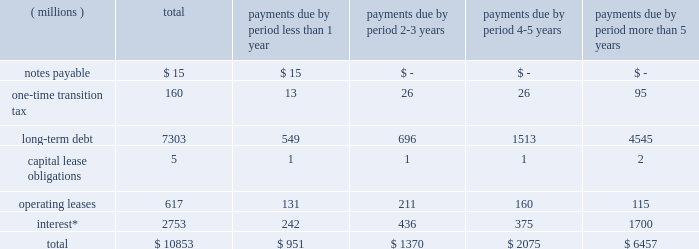Liquidity and capital resources we currently expect to fund all of our cash requirements which are reasonably foreseeable for 2018 , including scheduled debt repayments , new investments in the business , share repurchases , dividend payments , possible business acquisitions and pension contributions , with cash from operating activities , and as needed , additional short-term and/or long-term borrowings .
We continue to expect our operating cash flow to remain strong .
As of december 31 , 2017 , we had $ 211 million of cash and cash equivalents on hand , of which $ 151 million was held outside of the as of december 31 , 2016 , we had $ 327 million of cash and cash equivalents on hand , of which $ 184 million was held outside of the u.s .
As of december 31 , 2015 , we had $ 26 million of deferred tax liabilities for pre-acquisition foreign earnings associated with the legacy nalco entities and legacy champion entities that we intended to repatriate .
These liabilities were recorded as part of the respective purchase price accounting of each transaction .
The remaining foreign earnings were repatriated in 2016 , reducing the deferred tax liabilities to zero at december 31 , 2016 .
As of december 31 , 2017 we had a $ 2.0 billion multi-year credit facility , which expires in november 2022 .
The credit facility has been established with a diverse syndicate of banks .
There were no borrowings under our credit facility as of december 31 , 2017 or 2016 .
The credit facility supports our $ 2.0 billion u.s .
Commercial paper program and $ 2.0 billion european commercial paper program .
Combined borrowing under these two commercial paper programs may not exceed $ 2.0 billion .
At year-end , we had no amount outstanding under the european commercial paper program and no amount outstanding under the u.s .
Commercial paper program .
Additionally , we have uncommitted credit lines of $ 660 million with major international banks and financial institutions to support our general global funding needs .
Most of these lines are used to support global cash pooling structures .
Approximately $ 643 million of these credit lines were available for use as of year-end 2017 .
Bank supported letters of credit , surety bonds and guarantees total $ 198 million and represent commercial business transactions .
We do not have any other significant unconditional purchase obligations or commercial commitments .
As of december 31 , 2017 , our short-term borrowing program was rated a-2 by standard & poor 2019s and p-2 by moody 2019s .
As of december 31 , 2017 , standard & poor 2019s and moody 2019s rated our long-term credit at a- ( stable outlook ) and baa1 ( stable outlook ) , respectively .
A reduction in our credit ratings could limit or preclude our ability to issue commercial paper under our current programs , or could also adversely affect our ability to renew existing , or negotiate new , credit facilities in the future and could increase the cost of these facilities .
Should this occur , we could seek additional sources of funding , including issuing additional term notes or bonds .
In addition , we have the ability , at our option , to draw upon our $ 2.0 billion of committed credit facility .
We are in compliance with our debt covenants and other requirements of our credit agreements and indentures .
A schedule of our various obligations as of december 31 , 2017 are summarized in the table: .
* interest on variable rate debt was calculated using the interest rate at year-end 2017 .
During the fourth quarter of 2017 , we recorded a one-time transition tax related to enactment of the tax act .
The expense is primarily related to the one-time transition tax , which is payable over eight years .
As discussed further in note 12 , this balance is a provisional amount and is subject to adjustment during the measurement period of up to one year following the enactment of the tax act , as provided by recent sec guidance .
As of december 31 , 2017 , our gross liability for uncertain tax positions was $ 68 million .
We are not able to reasonably estimate the amount by which the liability will increase or decrease over an extended period of time or whether a cash settlement of the liability will be required .
Therefore , these amounts have been excluded from the schedule of contractual obligations. .
What percent of operating lease payments are due in less than one year? 
Computations: (131 / 617)
Answer: 0.21232. Liquidity and capital resources we currently expect to fund all of our cash requirements which are reasonably foreseeable for 2018 , including scheduled debt repayments , new investments in the business , share repurchases , dividend payments , possible business acquisitions and pension contributions , with cash from operating activities , and as needed , additional short-term and/or long-term borrowings .
We continue to expect our operating cash flow to remain strong .
As of december 31 , 2017 , we had $ 211 million of cash and cash equivalents on hand , of which $ 151 million was held outside of the as of december 31 , 2016 , we had $ 327 million of cash and cash equivalents on hand , of which $ 184 million was held outside of the u.s .
As of december 31 , 2015 , we had $ 26 million of deferred tax liabilities for pre-acquisition foreign earnings associated with the legacy nalco entities and legacy champion entities that we intended to repatriate .
These liabilities were recorded as part of the respective purchase price accounting of each transaction .
The remaining foreign earnings were repatriated in 2016 , reducing the deferred tax liabilities to zero at december 31 , 2016 .
As of december 31 , 2017 we had a $ 2.0 billion multi-year credit facility , which expires in november 2022 .
The credit facility has been established with a diverse syndicate of banks .
There were no borrowings under our credit facility as of december 31 , 2017 or 2016 .
The credit facility supports our $ 2.0 billion u.s .
Commercial paper program and $ 2.0 billion european commercial paper program .
Combined borrowing under these two commercial paper programs may not exceed $ 2.0 billion .
At year-end , we had no amount outstanding under the european commercial paper program and no amount outstanding under the u.s .
Commercial paper program .
Additionally , we have uncommitted credit lines of $ 660 million with major international banks and financial institutions to support our general global funding needs .
Most of these lines are used to support global cash pooling structures .
Approximately $ 643 million of these credit lines were available for use as of year-end 2017 .
Bank supported letters of credit , surety bonds and guarantees total $ 198 million and represent commercial business transactions .
We do not have any other significant unconditional purchase obligations or commercial commitments .
As of december 31 , 2017 , our short-term borrowing program was rated a-2 by standard & poor 2019s and p-2 by moody 2019s .
As of december 31 , 2017 , standard & poor 2019s and moody 2019s rated our long-term credit at a- ( stable outlook ) and baa1 ( stable outlook ) , respectively .
A reduction in our credit ratings could limit or preclude our ability to issue commercial paper under our current programs , or could also adversely affect our ability to renew existing , or negotiate new , credit facilities in the future and could increase the cost of these facilities .
Should this occur , we could seek additional sources of funding , including issuing additional term notes or bonds .
In addition , we have the ability , at our option , to draw upon our $ 2.0 billion of committed credit facility .
We are in compliance with our debt covenants and other requirements of our credit agreements and indentures .
A schedule of our various obligations as of december 31 , 2017 are summarized in the table: .
* interest on variable rate debt was calculated using the interest rate at year-end 2017 .
During the fourth quarter of 2017 , we recorded a one-time transition tax related to enactment of the tax act .
The expense is primarily related to the one-time transition tax , which is payable over eight years .
As discussed further in note 12 , this balance is a provisional amount and is subject to adjustment during the measurement period of up to one year following the enactment of the tax act , as provided by recent sec guidance .
As of december 31 , 2017 , our gross liability for uncertain tax positions was $ 68 million .
We are not able to reasonably estimate the amount by which the liability will increase or decrease over an extended period of time or whether a cash settlement of the liability will be required .
Therefore , these amounts have been excluded from the schedule of contractual obligations. .
What is the growth rate in the balance of cash and cash equivalents on hand from 2016 to 2017? 
Computations: ((211 - 327) / 327)
Answer: -0.35474. 